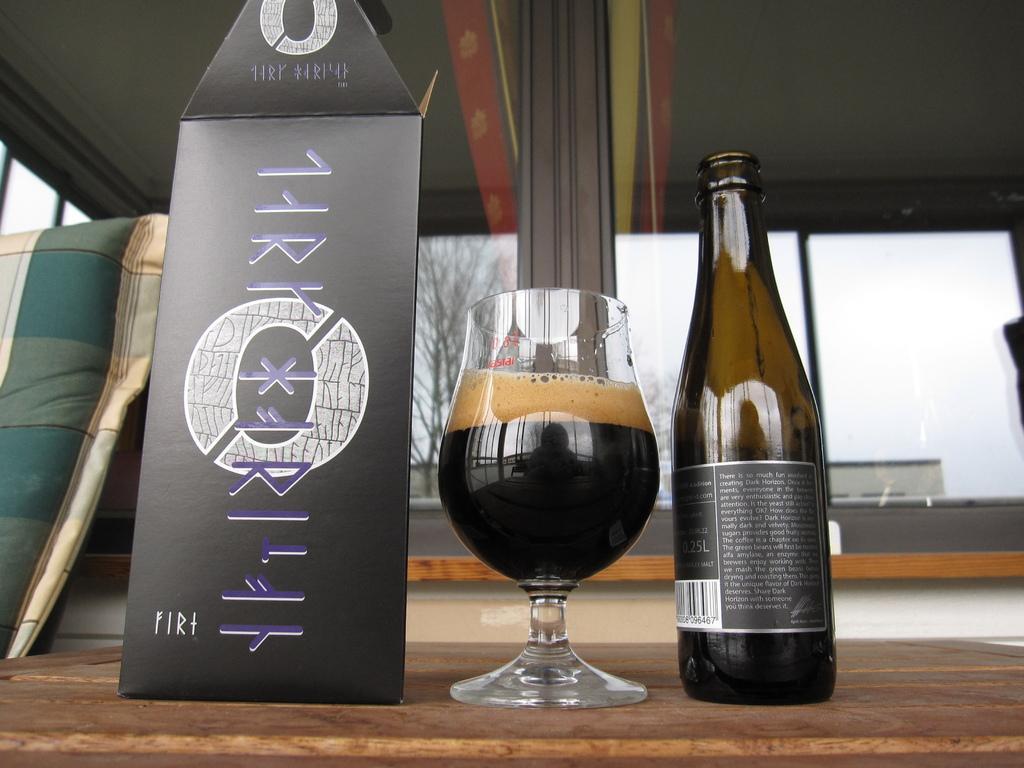In one or two sentences, can you explain what this image depicts? On the table there is a bottle, a glass with the liquid and a black color box. In to the left corner there is a pillow. And in the middle of the picture there is a pillar. And in the background we can see windows and trees. 